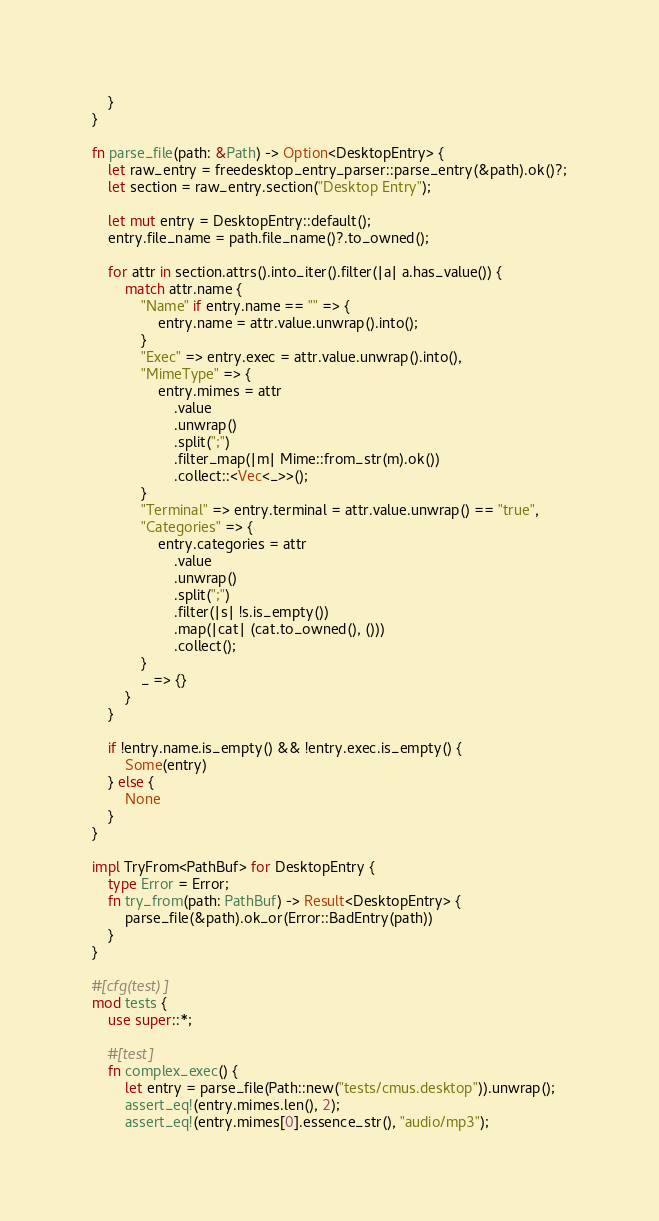Convert code to text. <code><loc_0><loc_0><loc_500><loc_500><_Rust_>    }
}

fn parse_file(path: &Path) -> Option<DesktopEntry> {
    let raw_entry = freedesktop_entry_parser::parse_entry(&path).ok()?;
    let section = raw_entry.section("Desktop Entry");

    let mut entry = DesktopEntry::default();
    entry.file_name = path.file_name()?.to_owned();

    for attr in section.attrs().into_iter().filter(|a| a.has_value()) {
        match attr.name {
            "Name" if entry.name == "" => {
                entry.name = attr.value.unwrap().into();
            }
            "Exec" => entry.exec = attr.value.unwrap().into(),
            "MimeType" => {
                entry.mimes = attr
                    .value
                    .unwrap()
                    .split(";")
                    .filter_map(|m| Mime::from_str(m).ok())
                    .collect::<Vec<_>>();
            }
            "Terminal" => entry.terminal = attr.value.unwrap() == "true",
            "Categories" => {
                entry.categories = attr
                    .value
                    .unwrap()
                    .split(";")
                    .filter(|s| !s.is_empty())
                    .map(|cat| (cat.to_owned(), ()))
                    .collect();
            }
            _ => {}
        }
    }

    if !entry.name.is_empty() && !entry.exec.is_empty() {
        Some(entry)
    } else {
        None
    }
}

impl TryFrom<PathBuf> for DesktopEntry {
    type Error = Error;
    fn try_from(path: PathBuf) -> Result<DesktopEntry> {
        parse_file(&path).ok_or(Error::BadEntry(path))
    }
}

#[cfg(test)]
mod tests {
    use super::*;

    #[test]
    fn complex_exec() {
        let entry = parse_file(Path::new("tests/cmus.desktop")).unwrap();
        assert_eq!(entry.mimes.len(), 2);
        assert_eq!(entry.mimes[0].essence_str(), "audio/mp3");</code> 